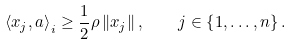Convert formula to latex. <formula><loc_0><loc_0><loc_500><loc_500>\left \langle x _ { j } , a \right \rangle _ { i } \geq \frac { 1 } { 2 } \rho \left \| x _ { j } \right \| , \quad j \in \left \{ 1 , \dots , n \right \} .</formula> 